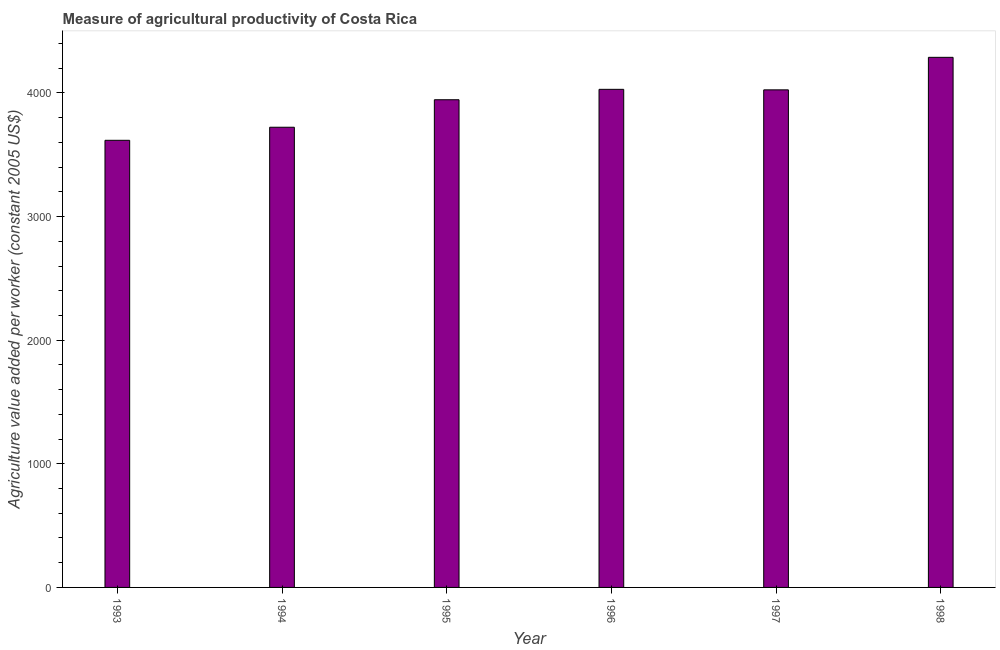Does the graph contain any zero values?
Ensure brevity in your answer.  No. Does the graph contain grids?
Offer a very short reply. No. What is the title of the graph?
Give a very brief answer. Measure of agricultural productivity of Costa Rica. What is the label or title of the Y-axis?
Make the answer very short. Agriculture value added per worker (constant 2005 US$). What is the agriculture value added per worker in 1994?
Make the answer very short. 3722.84. Across all years, what is the maximum agriculture value added per worker?
Your answer should be compact. 4288.42. Across all years, what is the minimum agriculture value added per worker?
Keep it short and to the point. 3617.18. In which year was the agriculture value added per worker maximum?
Ensure brevity in your answer.  1998. In which year was the agriculture value added per worker minimum?
Offer a terse response. 1993. What is the sum of the agriculture value added per worker?
Give a very brief answer. 2.36e+04. What is the difference between the agriculture value added per worker in 1993 and 1998?
Keep it short and to the point. -671.24. What is the average agriculture value added per worker per year?
Provide a short and direct response. 3938.08. What is the median agriculture value added per worker?
Offer a very short reply. 3985.29. Do a majority of the years between 1993 and 1997 (inclusive) have agriculture value added per worker greater than 4000 US$?
Offer a terse response. No. What is the ratio of the agriculture value added per worker in 1996 to that in 1998?
Give a very brief answer. 0.94. Is the agriculture value added per worker in 1993 less than that in 1997?
Your response must be concise. Yes. Is the difference between the agriculture value added per worker in 1996 and 1997 greater than the difference between any two years?
Ensure brevity in your answer.  No. What is the difference between the highest and the second highest agriculture value added per worker?
Provide a short and direct response. 258.97. What is the difference between the highest and the lowest agriculture value added per worker?
Ensure brevity in your answer.  671.24. In how many years, is the agriculture value added per worker greater than the average agriculture value added per worker taken over all years?
Your answer should be very brief. 4. How many bars are there?
Provide a short and direct response. 6. Are the values on the major ticks of Y-axis written in scientific E-notation?
Your answer should be very brief. No. What is the Agriculture value added per worker (constant 2005 US$) of 1993?
Offer a very short reply. 3617.18. What is the Agriculture value added per worker (constant 2005 US$) in 1994?
Make the answer very short. 3722.84. What is the Agriculture value added per worker (constant 2005 US$) of 1995?
Offer a terse response. 3945.26. What is the Agriculture value added per worker (constant 2005 US$) of 1996?
Make the answer very short. 4029.45. What is the Agriculture value added per worker (constant 2005 US$) in 1997?
Your response must be concise. 4025.32. What is the Agriculture value added per worker (constant 2005 US$) in 1998?
Offer a terse response. 4288.42. What is the difference between the Agriculture value added per worker (constant 2005 US$) in 1993 and 1994?
Your answer should be very brief. -105.66. What is the difference between the Agriculture value added per worker (constant 2005 US$) in 1993 and 1995?
Provide a short and direct response. -328.08. What is the difference between the Agriculture value added per worker (constant 2005 US$) in 1993 and 1996?
Give a very brief answer. -412.27. What is the difference between the Agriculture value added per worker (constant 2005 US$) in 1993 and 1997?
Offer a very short reply. -408.14. What is the difference between the Agriculture value added per worker (constant 2005 US$) in 1993 and 1998?
Provide a short and direct response. -671.24. What is the difference between the Agriculture value added per worker (constant 2005 US$) in 1994 and 1995?
Offer a terse response. -222.42. What is the difference between the Agriculture value added per worker (constant 2005 US$) in 1994 and 1996?
Offer a very short reply. -306.61. What is the difference between the Agriculture value added per worker (constant 2005 US$) in 1994 and 1997?
Offer a terse response. -302.48. What is the difference between the Agriculture value added per worker (constant 2005 US$) in 1994 and 1998?
Provide a succinct answer. -565.58. What is the difference between the Agriculture value added per worker (constant 2005 US$) in 1995 and 1996?
Offer a terse response. -84.18. What is the difference between the Agriculture value added per worker (constant 2005 US$) in 1995 and 1997?
Make the answer very short. -80.06. What is the difference between the Agriculture value added per worker (constant 2005 US$) in 1995 and 1998?
Give a very brief answer. -343.16. What is the difference between the Agriculture value added per worker (constant 2005 US$) in 1996 and 1997?
Offer a very short reply. 4.13. What is the difference between the Agriculture value added per worker (constant 2005 US$) in 1996 and 1998?
Offer a very short reply. -258.97. What is the difference between the Agriculture value added per worker (constant 2005 US$) in 1997 and 1998?
Offer a very short reply. -263.1. What is the ratio of the Agriculture value added per worker (constant 2005 US$) in 1993 to that in 1994?
Offer a very short reply. 0.97. What is the ratio of the Agriculture value added per worker (constant 2005 US$) in 1993 to that in 1995?
Offer a very short reply. 0.92. What is the ratio of the Agriculture value added per worker (constant 2005 US$) in 1993 to that in 1996?
Offer a terse response. 0.9. What is the ratio of the Agriculture value added per worker (constant 2005 US$) in 1993 to that in 1997?
Provide a succinct answer. 0.9. What is the ratio of the Agriculture value added per worker (constant 2005 US$) in 1993 to that in 1998?
Ensure brevity in your answer.  0.84. What is the ratio of the Agriculture value added per worker (constant 2005 US$) in 1994 to that in 1995?
Your response must be concise. 0.94. What is the ratio of the Agriculture value added per worker (constant 2005 US$) in 1994 to that in 1996?
Offer a terse response. 0.92. What is the ratio of the Agriculture value added per worker (constant 2005 US$) in 1994 to that in 1997?
Provide a succinct answer. 0.93. What is the ratio of the Agriculture value added per worker (constant 2005 US$) in 1994 to that in 1998?
Ensure brevity in your answer.  0.87. What is the ratio of the Agriculture value added per worker (constant 2005 US$) in 1995 to that in 1996?
Keep it short and to the point. 0.98. What is the ratio of the Agriculture value added per worker (constant 2005 US$) in 1995 to that in 1997?
Give a very brief answer. 0.98. What is the ratio of the Agriculture value added per worker (constant 2005 US$) in 1996 to that in 1997?
Your answer should be very brief. 1. What is the ratio of the Agriculture value added per worker (constant 2005 US$) in 1997 to that in 1998?
Your answer should be compact. 0.94. 